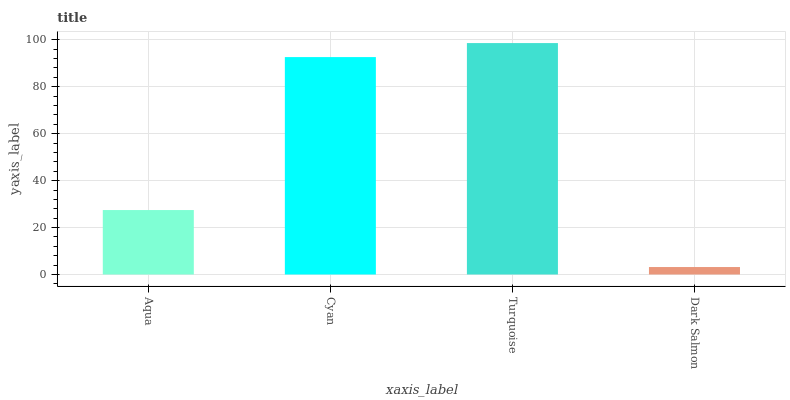Is Dark Salmon the minimum?
Answer yes or no. Yes. Is Turquoise the maximum?
Answer yes or no. Yes. Is Cyan the minimum?
Answer yes or no. No. Is Cyan the maximum?
Answer yes or no. No. Is Cyan greater than Aqua?
Answer yes or no. Yes. Is Aqua less than Cyan?
Answer yes or no. Yes. Is Aqua greater than Cyan?
Answer yes or no. No. Is Cyan less than Aqua?
Answer yes or no. No. Is Cyan the high median?
Answer yes or no. Yes. Is Aqua the low median?
Answer yes or no. Yes. Is Turquoise the high median?
Answer yes or no. No. Is Dark Salmon the low median?
Answer yes or no. No. 